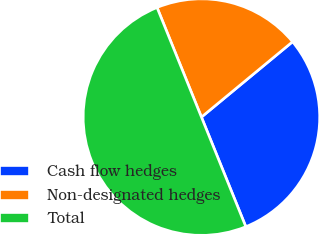<chart> <loc_0><loc_0><loc_500><loc_500><pie_chart><fcel>Cash flow hedges<fcel>Non-designated hedges<fcel>Total<nl><fcel>29.87%<fcel>20.13%<fcel>50.0%<nl></chart> 